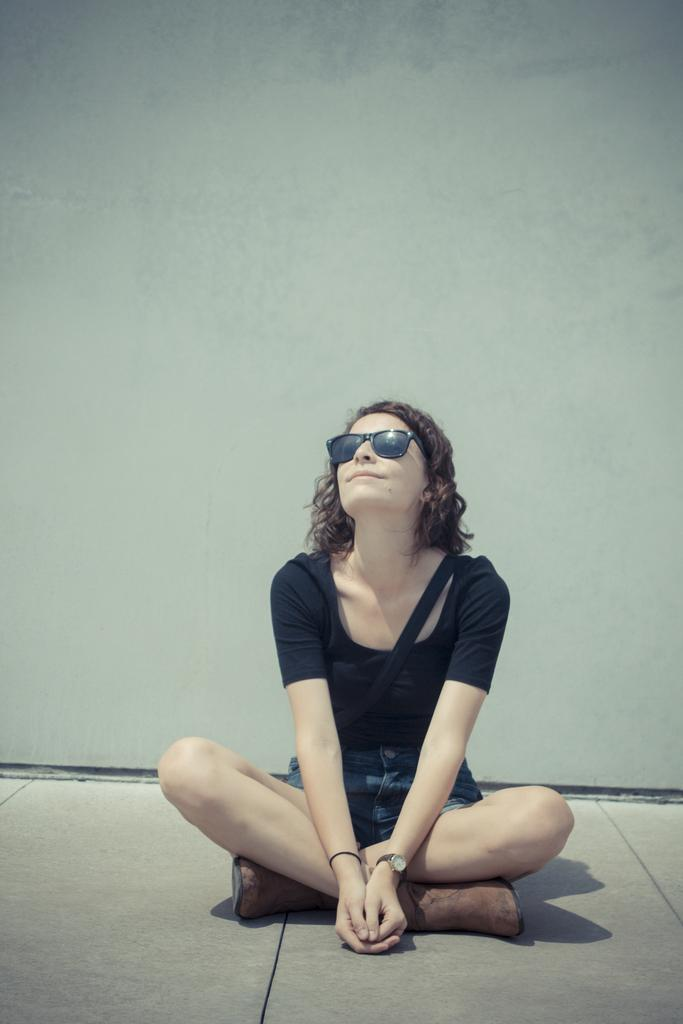What is the woman in the image doing? The woman is sitting on the floor. Can you describe any accessories the woman is wearing? The woman is wearing a watch on her left hand. What additional item can be seen in the image? There are goggles visible in the image. What type of linen is being used to dry the soda in the image? There is no linen or soda present in the image. 